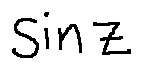<formula> <loc_0><loc_0><loc_500><loc_500>\sin z</formula> 